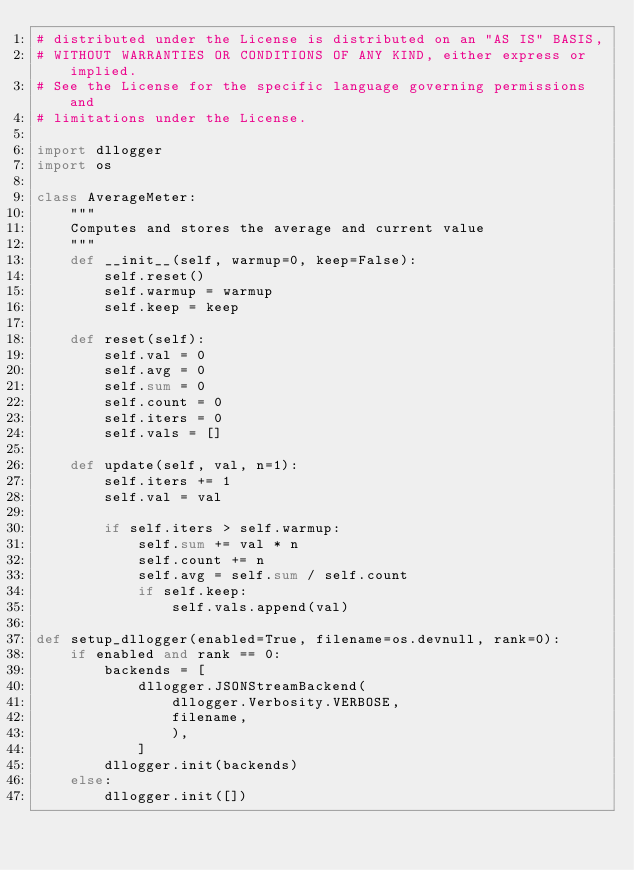Convert code to text. <code><loc_0><loc_0><loc_500><loc_500><_Python_># distributed under the License is distributed on an "AS IS" BASIS,
# WITHOUT WARRANTIES OR CONDITIONS OF ANY KIND, either express or implied.
# See the License for the specific language governing permissions and
# limitations under the License.

import dllogger
import os

class AverageMeter:
    """
    Computes and stores the average and current value
    """
    def __init__(self, warmup=0, keep=False):
        self.reset()
        self.warmup = warmup
        self.keep = keep

    def reset(self):
        self.val = 0
        self.avg = 0
        self.sum = 0
        self.count = 0
        self.iters = 0
        self.vals = []

    def update(self, val, n=1):
        self.iters += 1
        self.val = val

        if self.iters > self.warmup:
            self.sum += val * n
            self.count += n
            self.avg = self.sum / self.count
            if self.keep:
                self.vals.append(val)

def setup_dllogger(enabled=True, filename=os.devnull, rank=0):
    if enabled and rank == 0:
        backends = [
            dllogger.JSONStreamBackend(
                dllogger.Verbosity.VERBOSE,
                filename,
                ),
            ]
        dllogger.init(backends)
    else:
        dllogger.init([])
</code> 